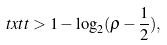Convert formula to latex. <formula><loc_0><loc_0><loc_500><loc_500>\ t x t t > 1 - \log _ { 2 } ( \rho - \frac { 1 } { 2 } ) ,</formula> 